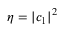<formula> <loc_0><loc_0><loc_500><loc_500>\eta = | c _ { 1 } | ^ { 2 }</formula> 